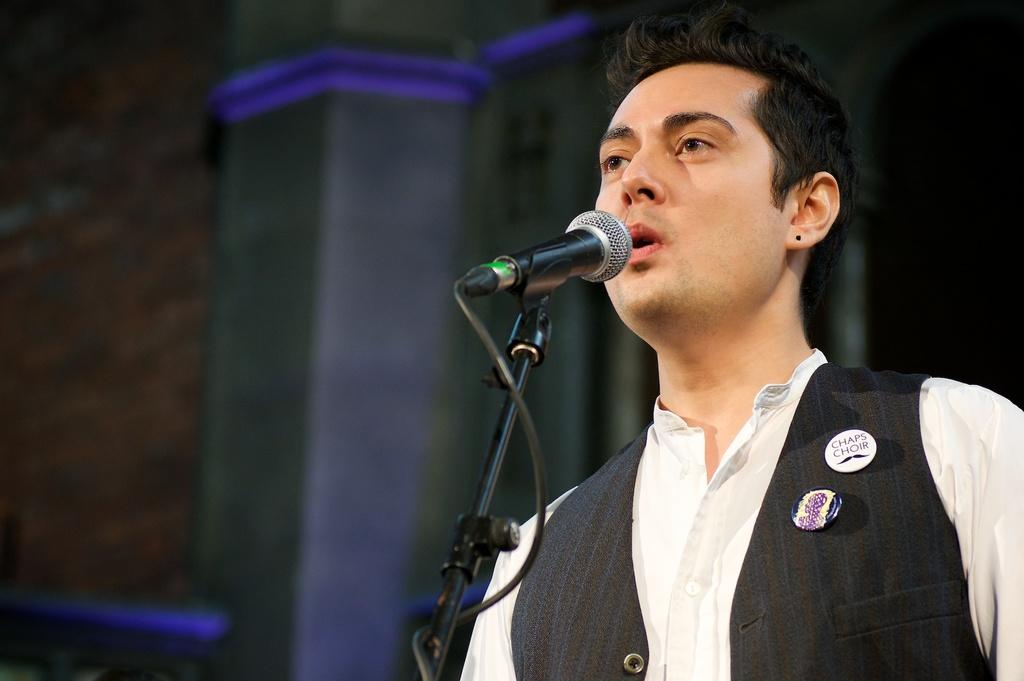Who or what is in the image? There is a person in the image. What is the person doing in the image? The person is standing in front of a mic. What can be seen in the background of the image? There are pillars visible in the background of the image. What is the tax rate for the person in the image? There is no information about tax rates in the image, as it only shows a person standing in front of a mic with pillars in the background. 